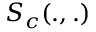<formula> <loc_0><loc_0><loc_500><loc_500>S _ { c } ( . , . )</formula> 